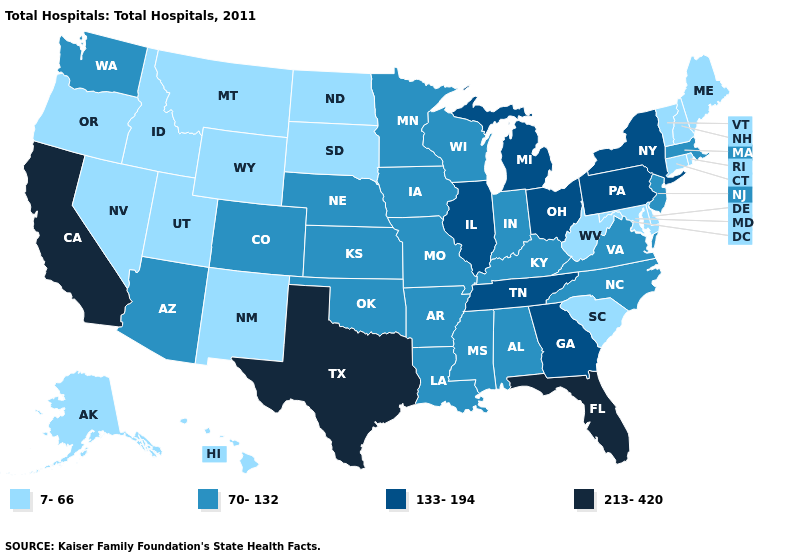What is the value of Pennsylvania?
Quick response, please. 133-194. Name the states that have a value in the range 133-194?
Concise answer only. Georgia, Illinois, Michigan, New York, Ohio, Pennsylvania, Tennessee. What is the value of Rhode Island?
Concise answer only. 7-66. Does Iowa have the lowest value in the MidWest?
Answer briefly. No. Does West Virginia have the lowest value in the USA?
Concise answer only. Yes. Among the states that border New York , does New Jersey have the lowest value?
Write a very short answer. No. What is the value of Georgia?
Be succinct. 133-194. Does Idaho have the lowest value in the USA?
Give a very brief answer. Yes. Name the states that have a value in the range 213-420?
Concise answer only. California, Florida, Texas. Which states have the lowest value in the USA?
Concise answer only. Alaska, Connecticut, Delaware, Hawaii, Idaho, Maine, Maryland, Montana, Nevada, New Hampshire, New Mexico, North Dakota, Oregon, Rhode Island, South Carolina, South Dakota, Utah, Vermont, West Virginia, Wyoming. Does Massachusetts have the lowest value in the Northeast?
Write a very short answer. No. What is the value of Connecticut?
Keep it brief. 7-66. What is the highest value in the MidWest ?
Write a very short answer. 133-194. What is the value of Massachusetts?
Short answer required. 70-132. Does Mississippi have the highest value in the USA?
Give a very brief answer. No. 